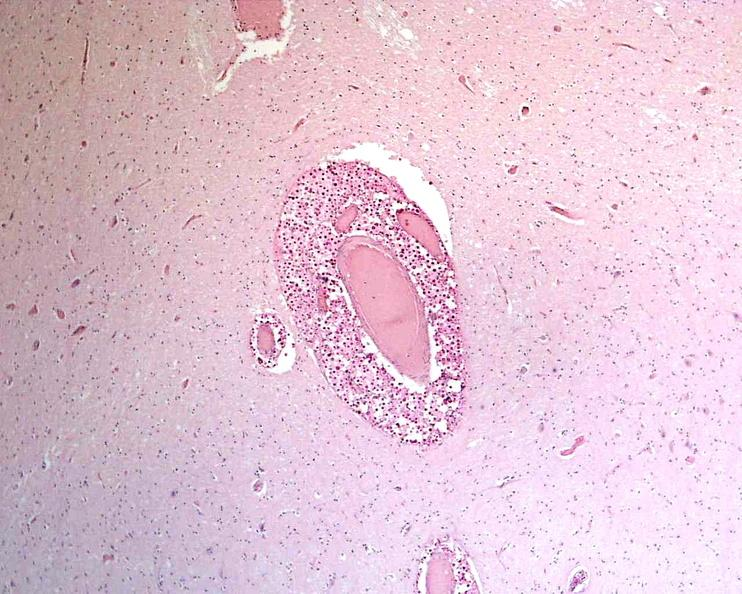s nervous present?
Answer the question using a single word or phrase. Yes 